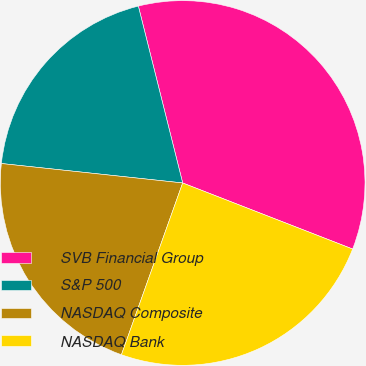Convert chart. <chart><loc_0><loc_0><loc_500><loc_500><pie_chart><fcel>SVB Financial Group<fcel>S&P 500<fcel>NASDAQ Composite<fcel>NASDAQ Bank<nl><fcel>34.81%<fcel>19.39%<fcel>21.25%<fcel>24.55%<nl></chart> 